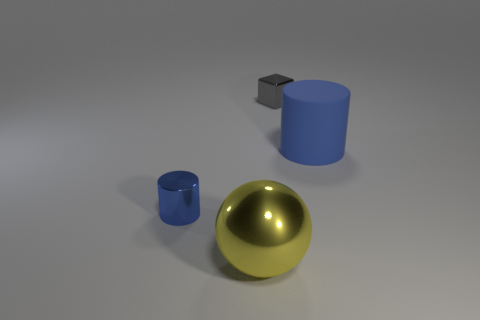Can you estimate the relative sizes of these objects? Based on the perspective in the image, the gold sphere seems to be the largest object, followed by the blue cylinder. The small cube behind the cylinder appears to be the smallest object among them. 